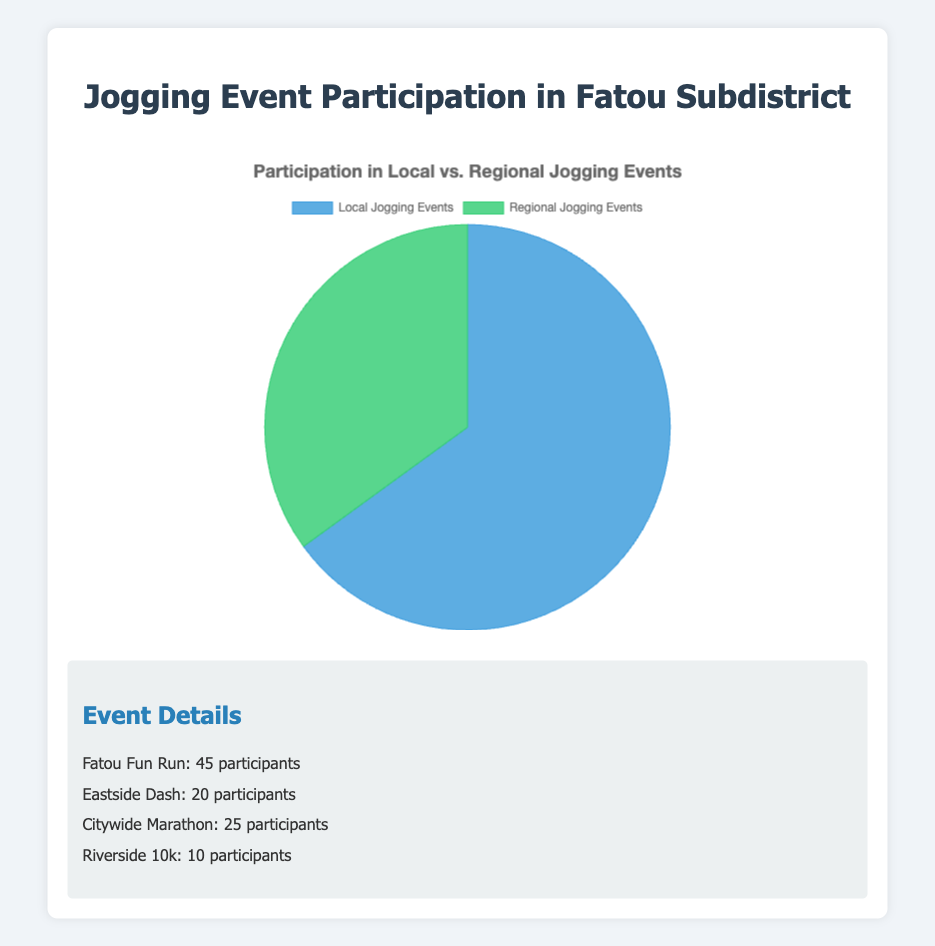Which event had the highest participation at local jogging events? According to the data, the Fatou Fun Run had 45 participants, which is more than the Eastside Dash's 20 participants
Answer: Fatou Fun Run What percentage of total jogging event participation was in local events? The total number of participants is 65 (local) + 35 (regional) = 100. Local events had 65 participants which is 65/100 * 100 = 65% of the total
Answer: 65% How many more participants were there in local jogging events compared to regional jogging events? There were 65 participants in local events and 35 in regional events. The difference is 65 - 35 = 30
Answer: 30 What is the participation ratio between local and regional events? Local participation is 65 and regional participation is 35. The ratio is 65:35, which simplifies to 13:7
Answer: 13:7 Which regional event had more participants, Citywide Marathon or Riverside 10k? The Citywide Marathon had 25 participants, while the Riverside 10k had 10. Therefore, the Citywide Marathon had more participants
Answer: Citywide Marathon What is the average participation in local events? There are 2 local events. Adding their participation numbers gives 45 + 20 = 65. Dividing by 2 gives an average of 65 / 2 = 32.5
Answer: 32.5 If the total participation for local events increased by 10%, what would be the new participation number? A 10% increase on the current 65 participants is 65 * 0.10 = 6.5. Adding this to the current participation, 65 + 6.5 = 71.5
Answer: 71.5 How many participants took part in all jogging events combined? Adding up the local and regional participants gives 65 (local) + 35 (regional) = 100
Answer: 100 What percentage of the total regional event participation did the Citywide Marathon and Riverside 10k have individually? The Citywide Marathon had 25 participants and the Riverside 10k had 10 out of the total 35 regional participants. Citywide Marathon: (25/35) * 100 ≈ 71.4%, Riverside 10k: (10/35) * 100 ≈ 28.6%
Answer: Citywide Marathon: 71.4%, Riverside 10k: 28.6% What color representation is used for local events in the pie chart? The pie chart uses excerpts of specific shades, but it is described that local events are colored in a blue-like shade
Answer: Blue 